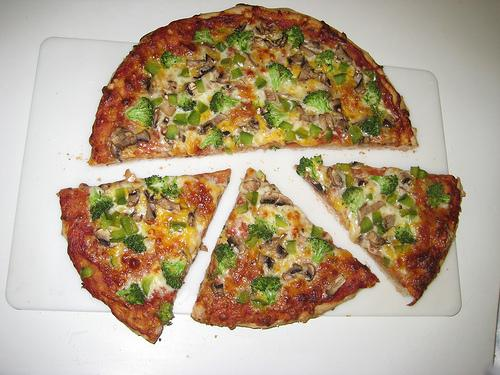Mention the key ingredients visible in the pizza displayed in the image. The pizza features mushrooms, cheese, broccoli, red sauce, and thinly sliced green peppers as its key ingredients. Give a brief description of the overall scene in the image. A half veggie pizza with mushrooms, cheese, and broccoli rests on a clear cutting board on a white tablecloth, with different slices in focus. Point out one remarkable aspect of the pizza toppings visible in the image. The thinly sliced mushrooms and diced green peppers seem to be the most remarkable aspect of the pizza toppings. What kind of pizza is shown in the image and what is its current state? The image displays a half of a veggie pizza with mushrooms, cheese, and broccoli, partially cut into slices on a clear cutting board. In one sentence, describe the main elements visible in the image. The image features a half veggie pizza with various toppings like mushrooms, cheese, broccoli, and bell peppers, cut into uneven pieces and resting on a clear cutting board over a white tablecloth. What is unique about the cheese on the pizza in the image? The cheese on the pizza has a yellow-orange hue, with bubbles that are caramelized on top. What is the general condition of the cheese on the pizza in the image? The cheese on the pizza appears well done, with a yellow-orange color and caramelized bubbles on the surface. What type of cutting board does the pizza in the image rest on? The pizza rests on a clear cutting board that appears to be slightly small for its size. Describe the condition of the pizza crust in the image. The pizza crust appears thin and well done, with a crunchy part and caramelized cheese bubbles on top. How many slices of pizza are visible in the image, and what are their sizes? There are five distinct slices of pizza visible in the image, including four uneven pieces and a well-done thin crust slice. 